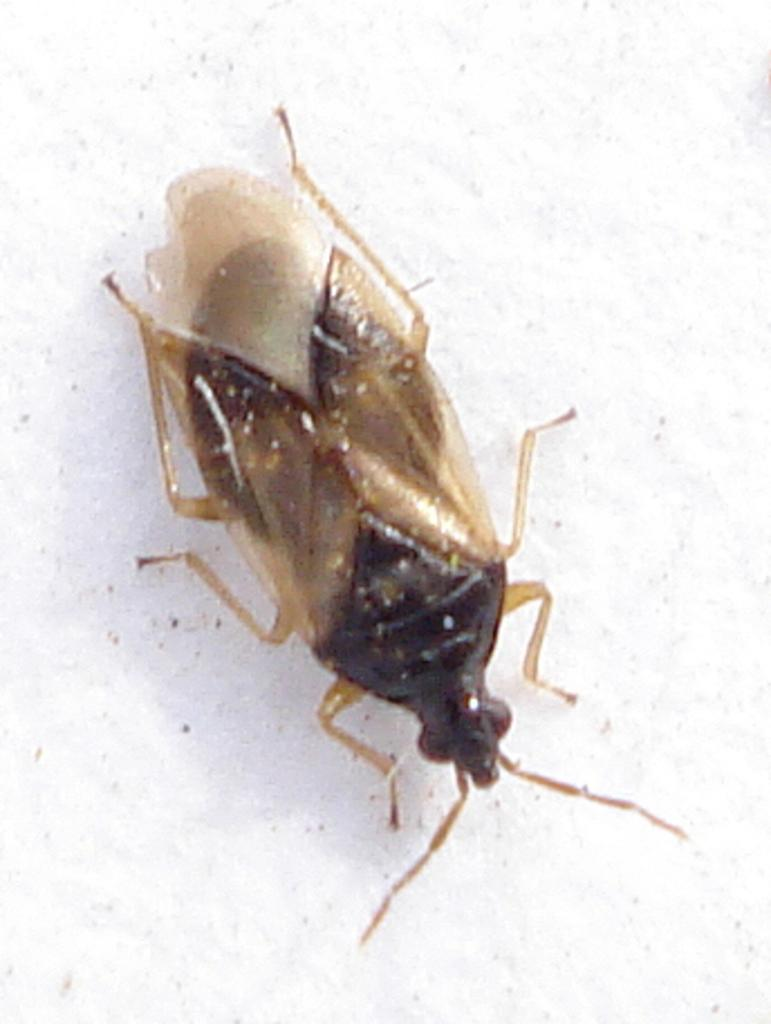What type of creature can be seen in the image? There is a bug in the image. What type of office furniture can be seen in the image? There is no office furniture present in the image; it features a bug. What type of tongue can be seen in the image? There is no tongue present in the image; it features a bug. 